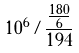Convert formula to latex. <formula><loc_0><loc_0><loc_500><loc_500>1 0 ^ { 6 } / \frac { \frac { 1 8 0 } { 6 } } { 1 9 4 }</formula> 